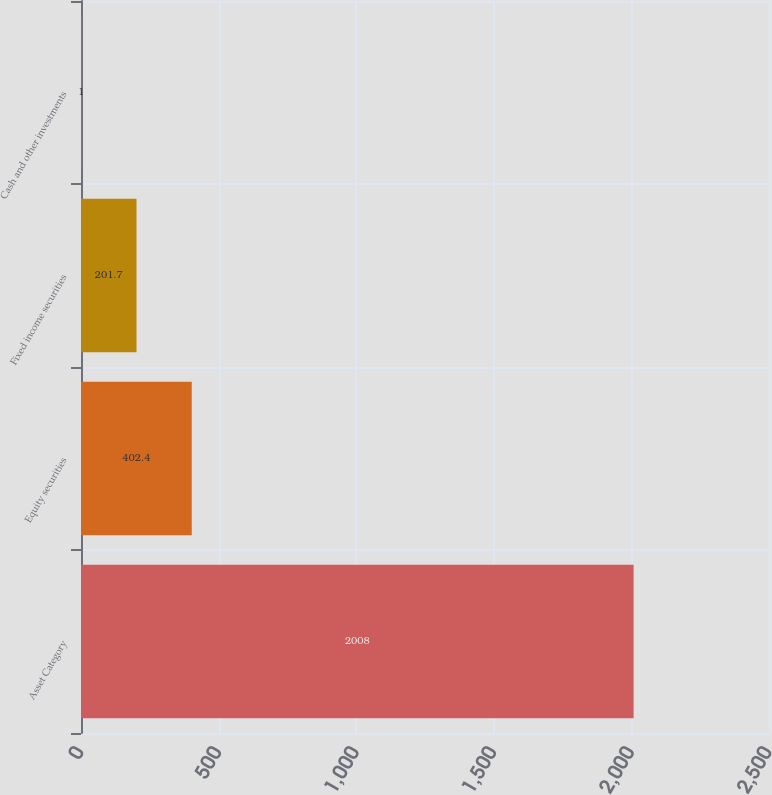Convert chart. <chart><loc_0><loc_0><loc_500><loc_500><bar_chart><fcel>Asset Category<fcel>Equity securities<fcel>Fixed income securities<fcel>Cash and other investments<nl><fcel>2008<fcel>402.4<fcel>201.7<fcel>1<nl></chart> 